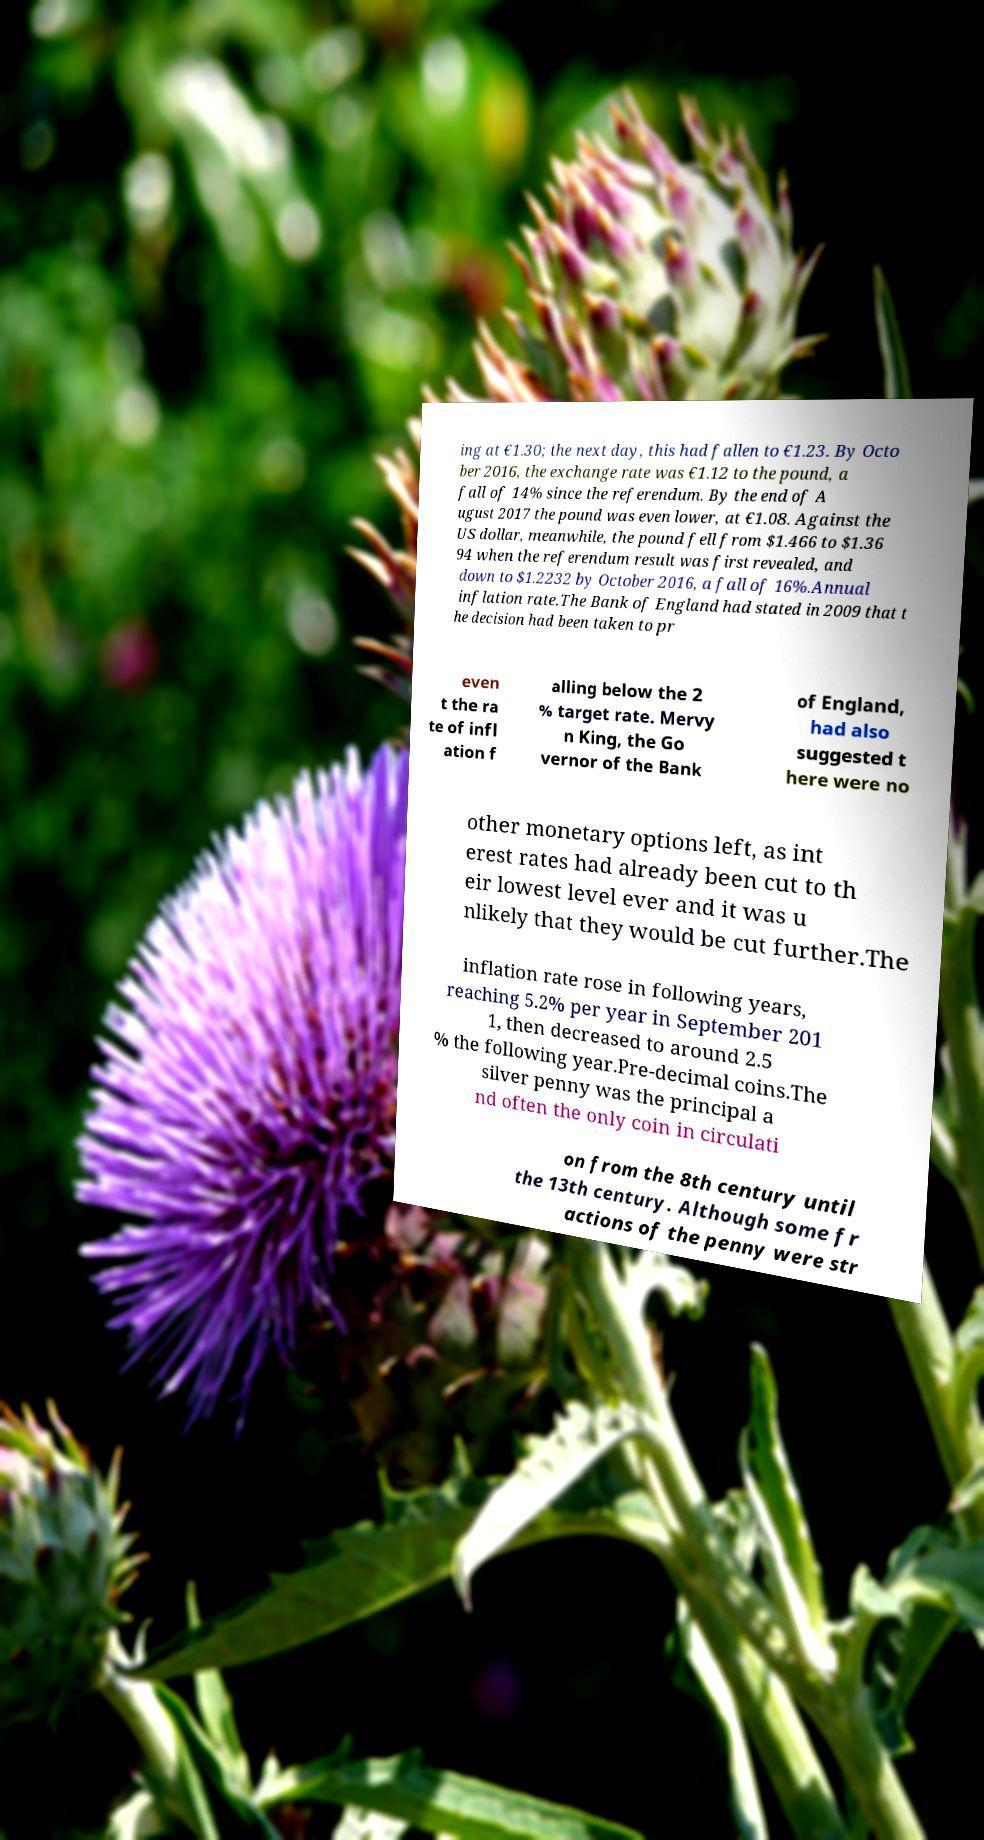For documentation purposes, I need the text within this image transcribed. Could you provide that? ing at €1.30; the next day, this had fallen to €1.23. By Octo ber 2016, the exchange rate was €1.12 to the pound, a fall of 14% since the referendum. By the end of A ugust 2017 the pound was even lower, at €1.08. Against the US dollar, meanwhile, the pound fell from $1.466 to $1.36 94 when the referendum result was first revealed, and down to $1.2232 by October 2016, a fall of 16%.Annual inflation rate.The Bank of England had stated in 2009 that t he decision had been taken to pr even t the ra te of infl ation f alling below the 2 % target rate. Mervy n King, the Go vernor of the Bank of England, had also suggested t here were no other monetary options left, as int erest rates had already been cut to th eir lowest level ever and it was u nlikely that they would be cut further.The inflation rate rose in following years, reaching 5.2% per year in September 201 1, then decreased to around 2.5 % the following year.Pre-decimal coins.The silver penny was the principal a nd often the only coin in circulati on from the 8th century until the 13th century. Although some fr actions of the penny were str 